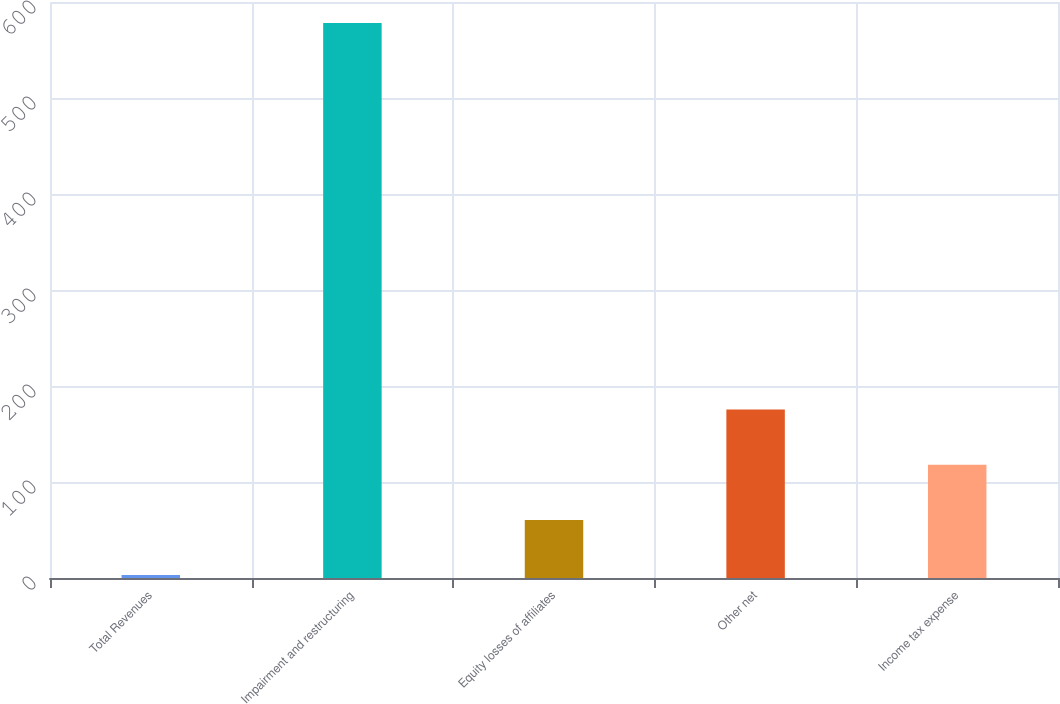Convert chart to OTSL. <chart><loc_0><loc_0><loc_500><loc_500><bar_chart><fcel>Total Revenues<fcel>Impairment and restructuring<fcel>Equity losses of affiliates<fcel>Other net<fcel>Income tax expense<nl><fcel>3<fcel>578<fcel>60.5<fcel>175.5<fcel>118<nl></chart> 